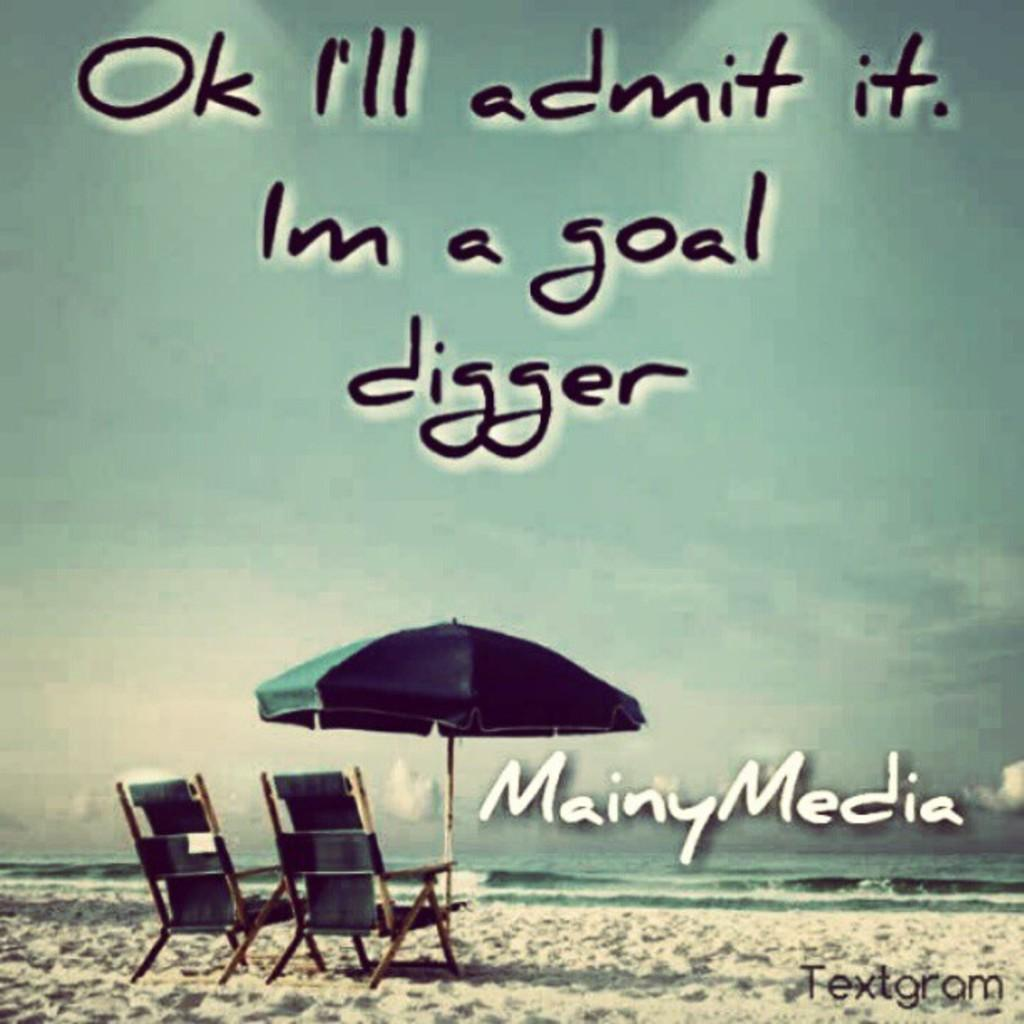What object is present in the image that can provide shade? There is an umbrella in the image. What is the surface on which the chairs are placed in the image? The chairs are on the sand in the image. What can be seen besides the sand and chairs in the image? There is water visible in the image. What is written or printed in the image? There is some text in the image. What can be seen in the background of the image? The sky is visible in the background of the image. How many apples are being held by the giants in the image? There are no giants or apples present in the image. What type of medical treatment is being administered to the patients in the hospital in the image? There is no hospital or patients present in the image. 